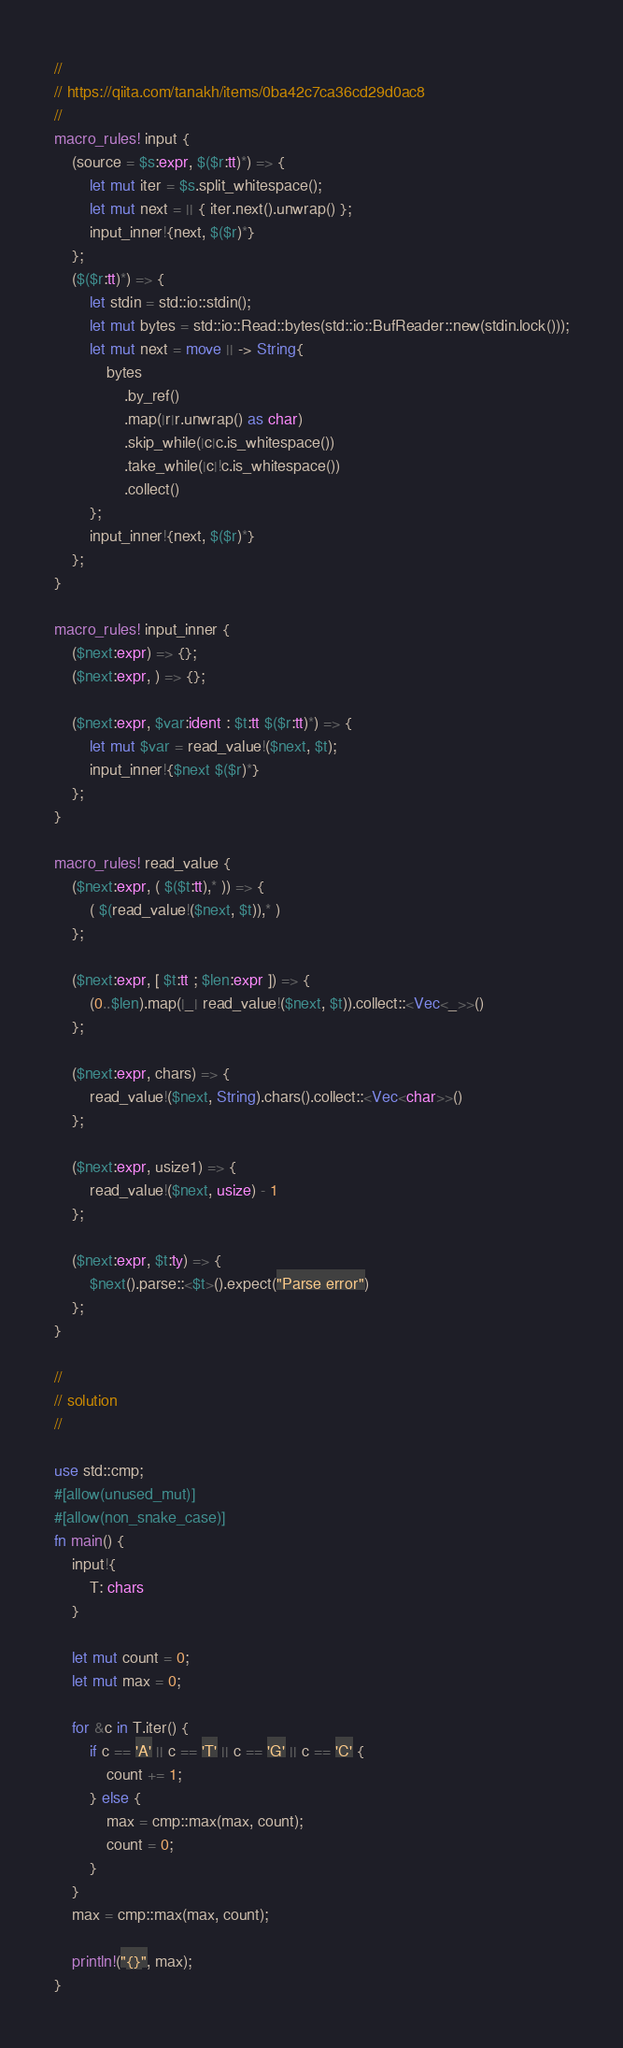Convert code to text. <code><loc_0><loc_0><loc_500><loc_500><_Rust_>//
// https://qiita.com/tanakh/items/0ba42c7ca36cd29d0ac8
//
macro_rules! input {
    (source = $s:expr, $($r:tt)*) => {
        let mut iter = $s.split_whitespace();
        let mut next = || { iter.next().unwrap() };
        input_inner!{next, $($r)*}
    };
    ($($r:tt)*) => {
        let stdin = std::io::stdin();
        let mut bytes = std::io::Read::bytes(std::io::BufReader::new(stdin.lock()));
        let mut next = move || -> String{
            bytes
                .by_ref()
                .map(|r|r.unwrap() as char)
                .skip_while(|c|c.is_whitespace())
                .take_while(|c|!c.is_whitespace())
                .collect()
        };
        input_inner!{next, $($r)*}
    };
}

macro_rules! input_inner {
    ($next:expr) => {};
    ($next:expr, ) => {};

    ($next:expr, $var:ident : $t:tt $($r:tt)*) => {
        let mut $var = read_value!($next, $t);
        input_inner!{$next $($r)*}
    };
}

macro_rules! read_value {
    ($next:expr, ( $($t:tt),* )) => {
        ( $(read_value!($next, $t)),* )
    };

    ($next:expr, [ $t:tt ; $len:expr ]) => {
        (0..$len).map(|_| read_value!($next, $t)).collect::<Vec<_>>()
    };

    ($next:expr, chars) => {
        read_value!($next, String).chars().collect::<Vec<char>>()
    };

    ($next:expr, usize1) => {
        read_value!($next, usize) - 1
    };

    ($next:expr, $t:ty) => {
        $next().parse::<$t>().expect("Parse error")
    };
}

//
// solution 
//

use std::cmp;
#[allow(unused_mut)]
#[allow(non_snake_case)]
fn main() {
    input!{
        T: chars
    }

    let mut count = 0;
    let mut max = 0;

    for &c in T.iter() {
        if c == 'A' || c == 'T' || c == 'G' || c == 'C' {
            count += 1;
        } else {
            max = cmp::max(max, count);
            count = 0;
        }
    }
    max = cmp::max(max, count);

    println!("{}", max);
}
</code> 